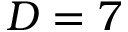Convert formula to latex. <formula><loc_0><loc_0><loc_500><loc_500>D = 7</formula> 